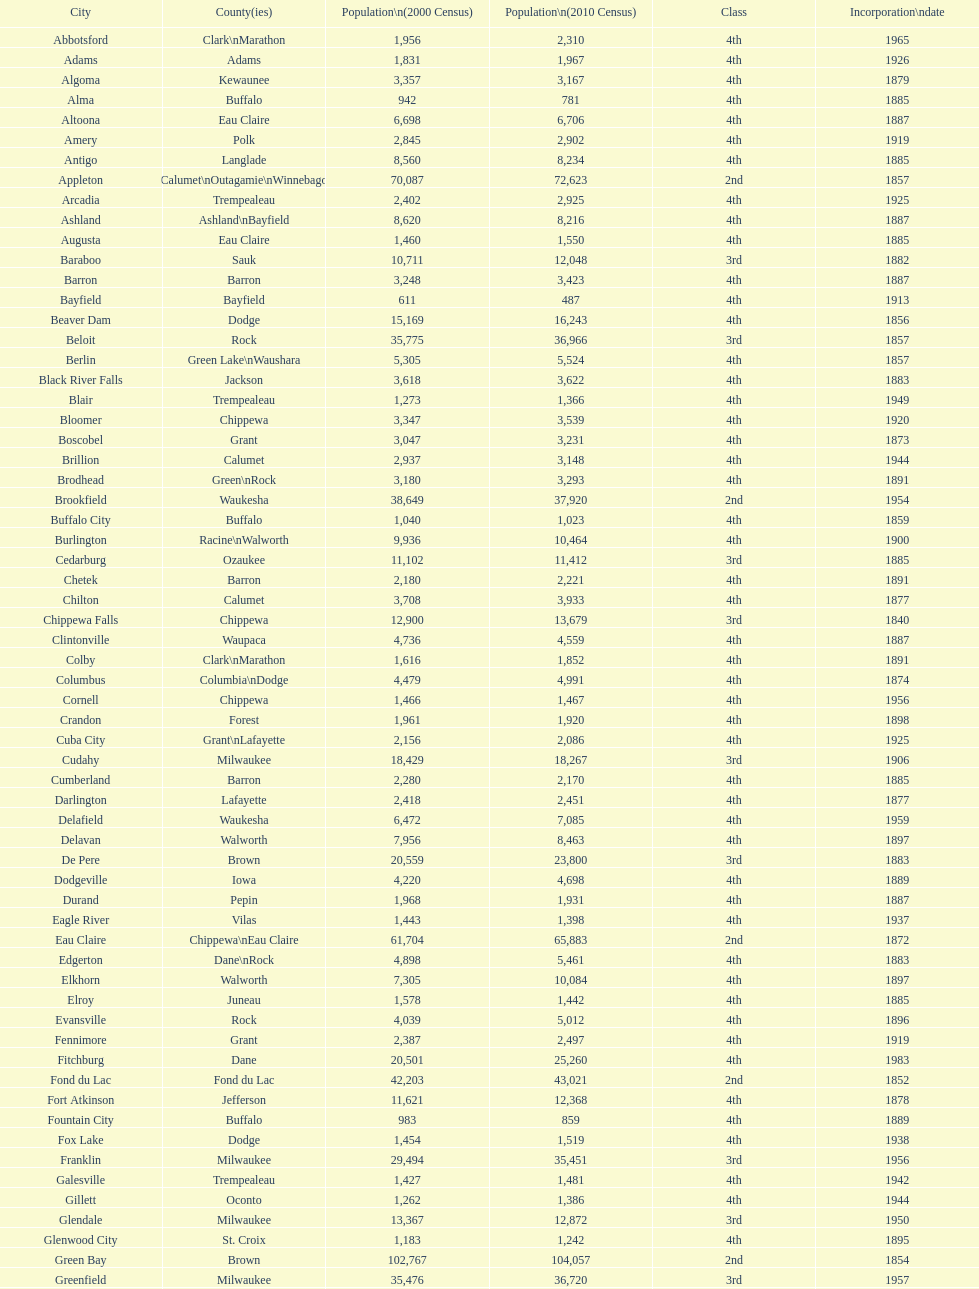In the 2010 census, which city had the highest population? Milwaukee. 